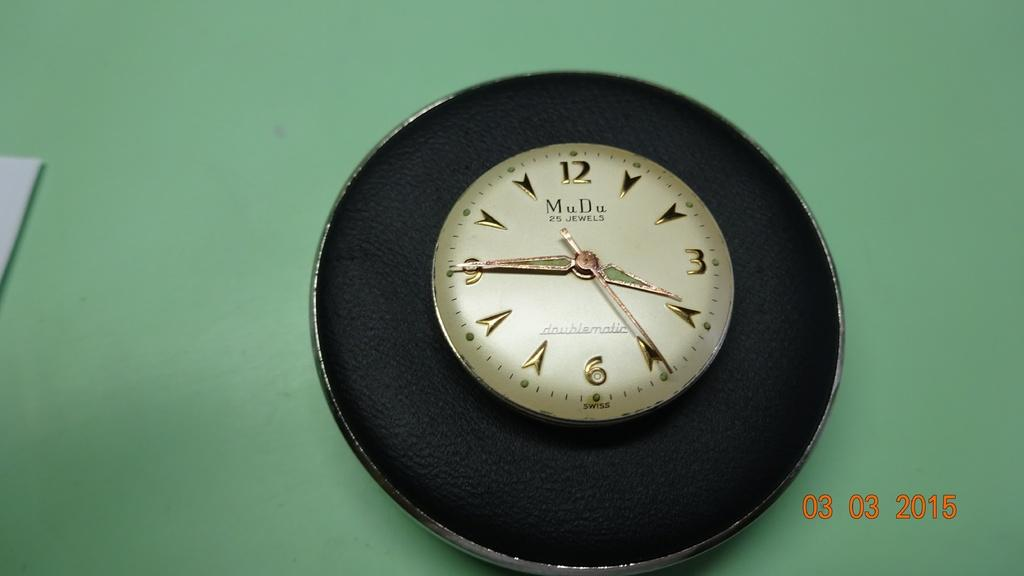<image>
Relay a brief, clear account of the picture shown. A photo taken on March 3rd of 2015. 